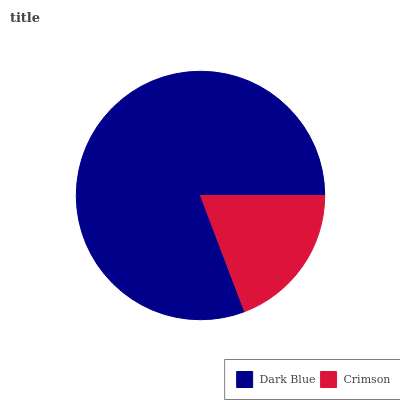Is Crimson the minimum?
Answer yes or no. Yes. Is Dark Blue the maximum?
Answer yes or no. Yes. Is Crimson the maximum?
Answer yes or no. No. Is Dark Blue greater than Crimson?
Answer yes or no. Yes. Is Crimson less than Dark Blue?
Answer yes or no. Yes. Is Crimson greater than Dark Blue?
Answer yes or no. No. Is Dark Blue less than Crimson?
Answer yes or no. No. Is Dark Blue the high median?
Answer yes or no. Yes. Is Crimson the low median?
Answer yes or no. Yes. Is Crimson the high median?
Answer yes or no. No. Is Dark Blue the low median?
Answer yes or no. No. 